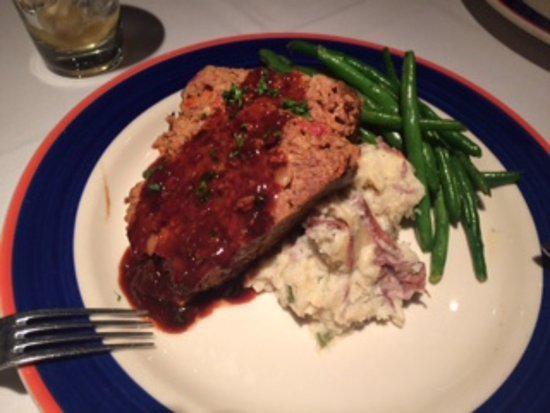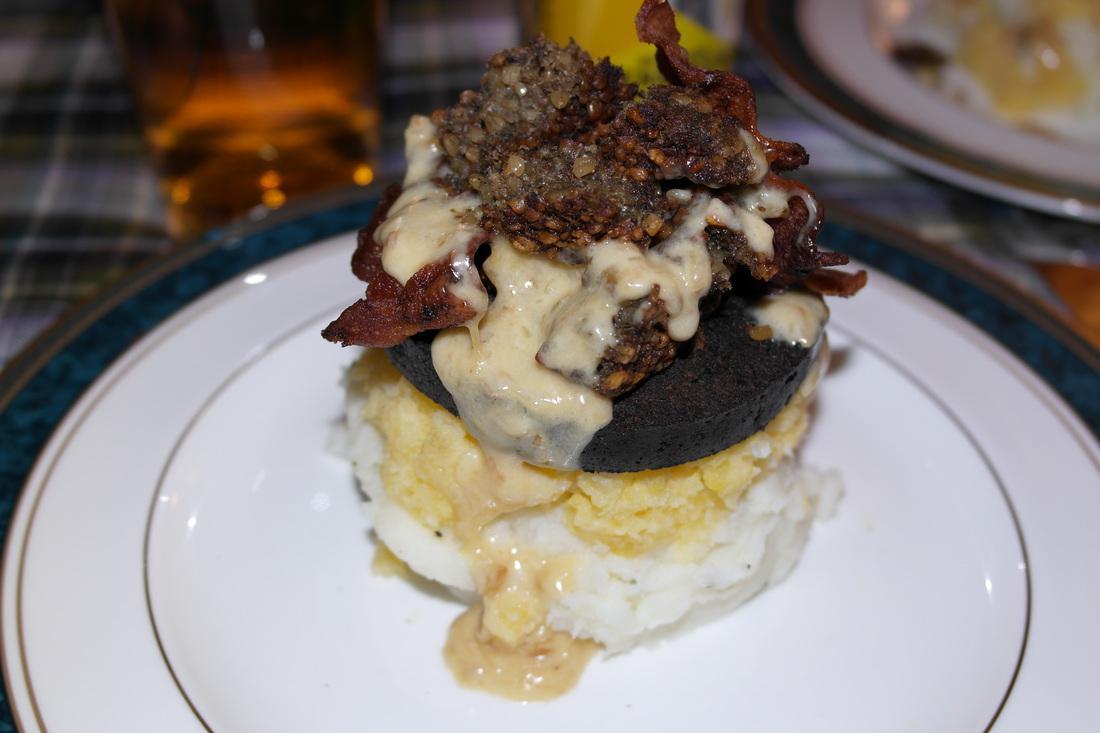The first image is the image on the left, the second image is the image on the right. For the images shown, is this caption "The right dish is entirely layered, the left dish has a green vegetable." true? Answer yes or no. Yes. The first image is the image on the left, the second image is the image on the right. Evaluate the accuracy of this statement regarding the images: "A serving of cooked green vegetables is on a plate next to some type of prepared meat.". Is it true? Answer yes or no. Yes. 